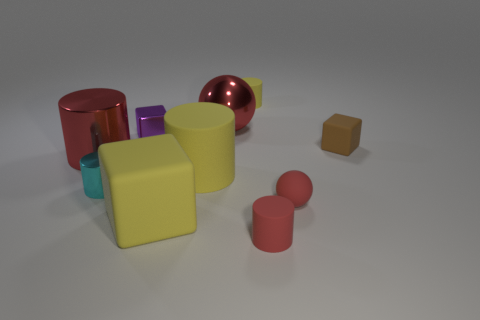Subtract all blocks. How many objects are left? 7 Subtract 0 brown balls. How many objects are left? 10 Subtract all tiny objects. Subtract all large yellow rubber cylinders. How many objects are left? 3 Add 8 small red matte cylinders. How many small red matte cylinders are left? 9 Add 2 yellow matte blocks. How many yellow matte blocks exist? 3 